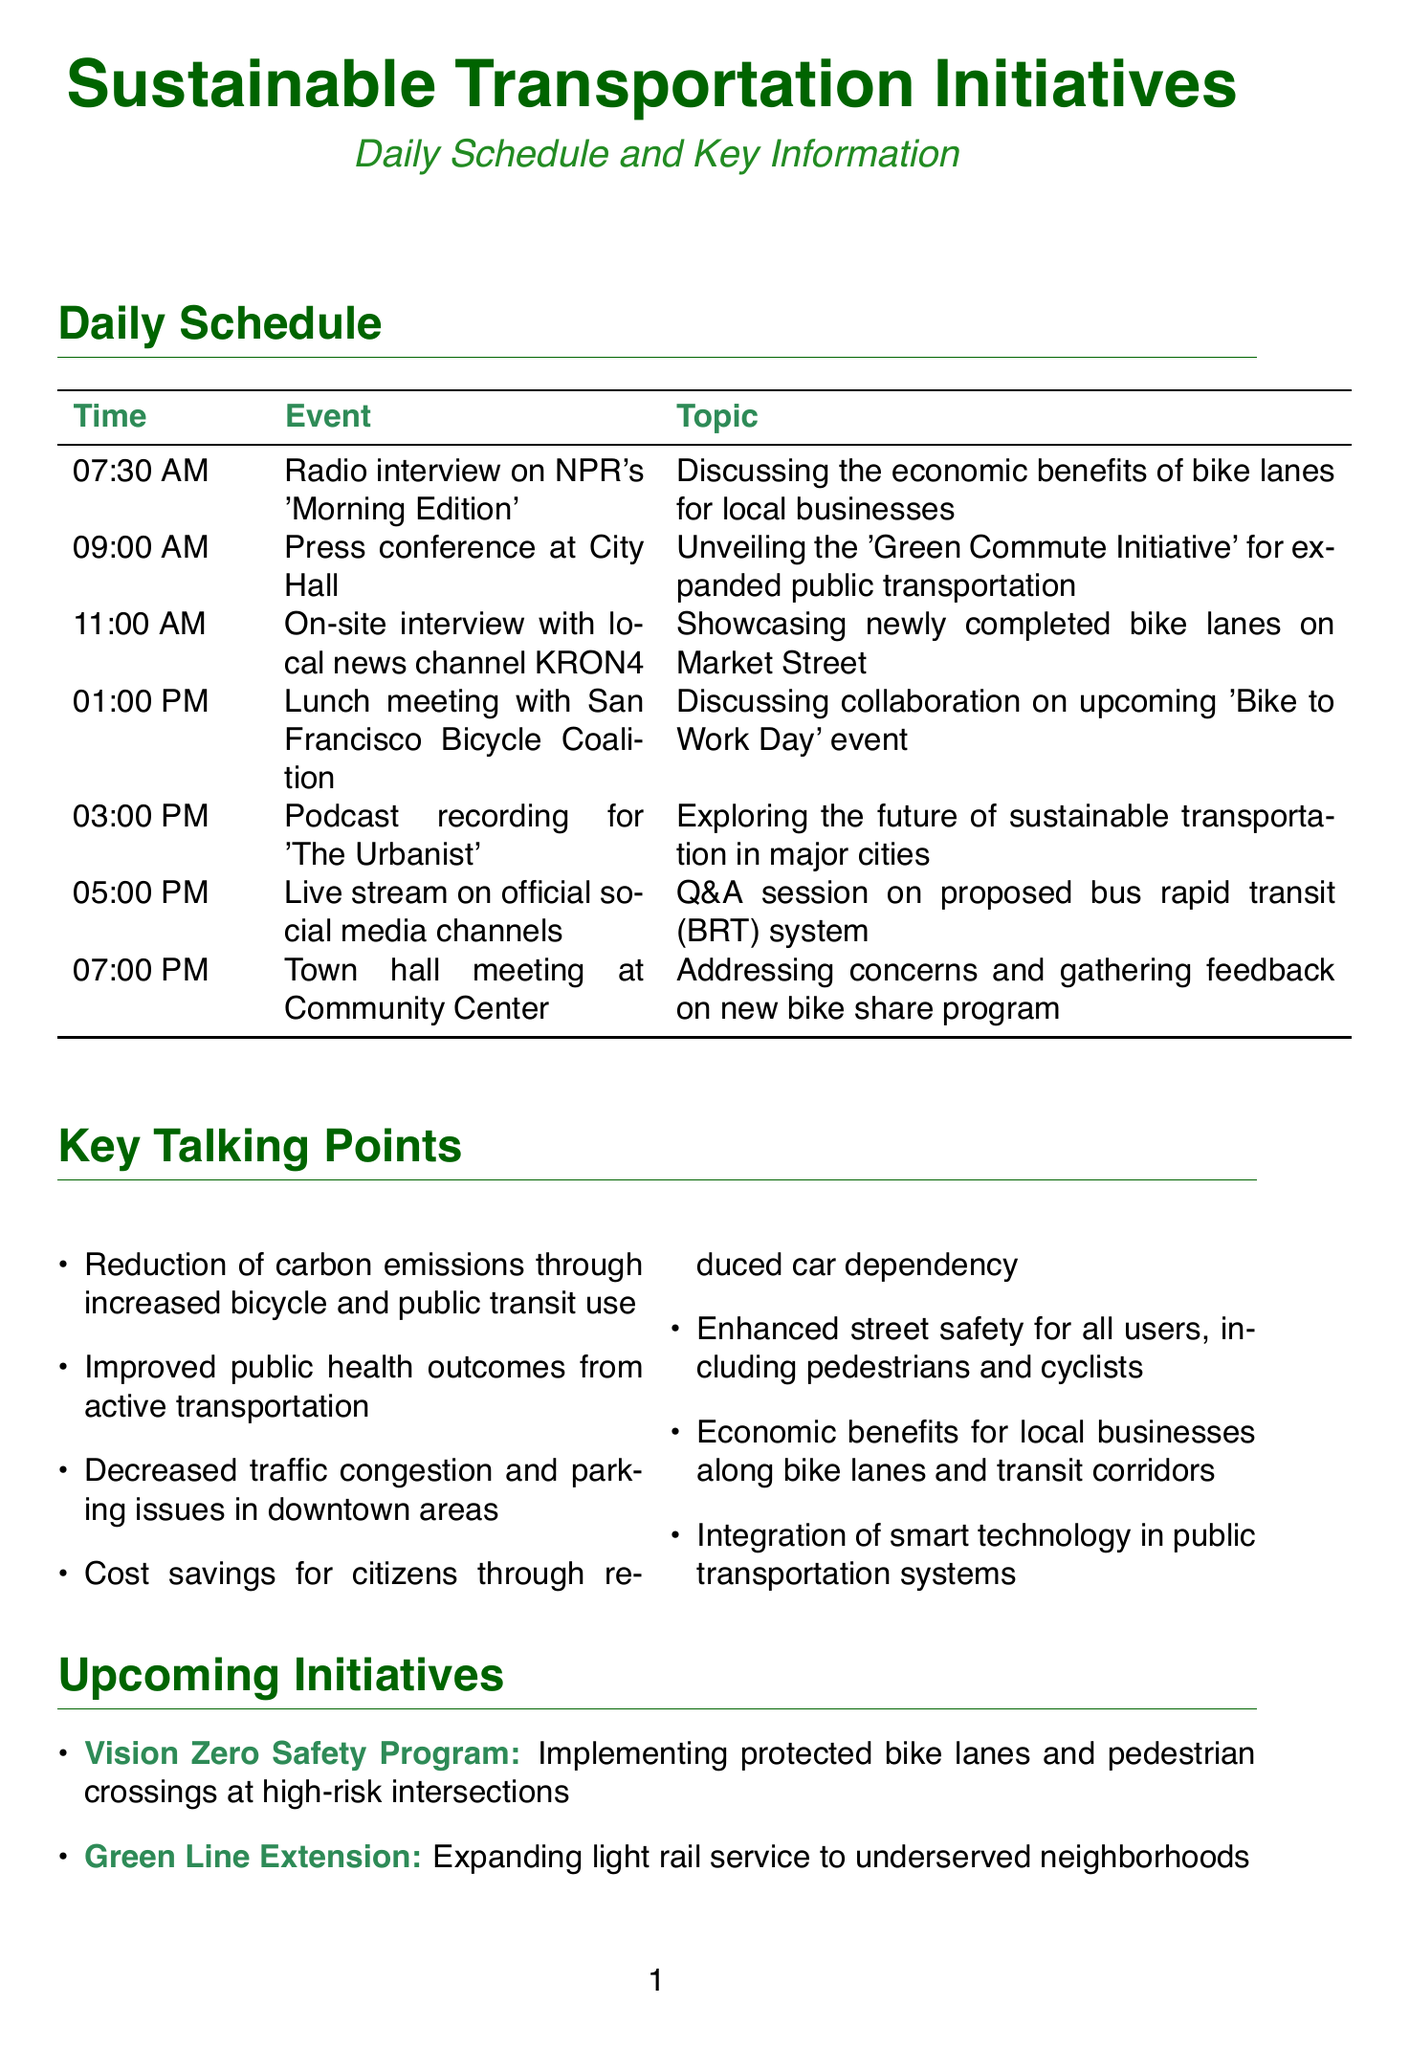What is the topic of the 9:00 AM event? The 9:00 AM event is a press conference at City Hall, which unveils the 'Green Commute Initiative' for expanded public transportation.
Answer: Unveiling the 'Green Commute Initiative' for expanded public transportation What time is the live stream scheduled? The live stream is scheduled for 5:00 PM according to the daily schedule.
Answer: 5:00 PM How many key talking points are listed in the document? The document lists seven key talking points regarding sustainable transportation initiatives.
Answer: 7 Which stakeholder is involved in urban planning? The document identifies urban planning experts from UC Berkeley as a key stakeholder involved in sustainable transportation initiatives.
Answer: Urban planning experts from UC Berkeley What is the main focus of the 3:00 PM podcast recording? The podcast recording at 3:00 PM focuses on the future of sustainable transportation in major cities as stated in the schedule.
Answer: Exploring the future of sustainable transportation in major cities What initiative focuses on recognizing businesses that support cycling infrastructure? The 'Bike-friendly Business Certification' initiative is aimed at recognizing and incentivizing businesses that support cycling infrastructure.
Answer: Bike-friendly Business Certification How many events are scheduled after the town hall meeting? The document outlines that there are no additional events after the 7:00 PM town hall meeting, making this the last event of the day.
Answer: 0 